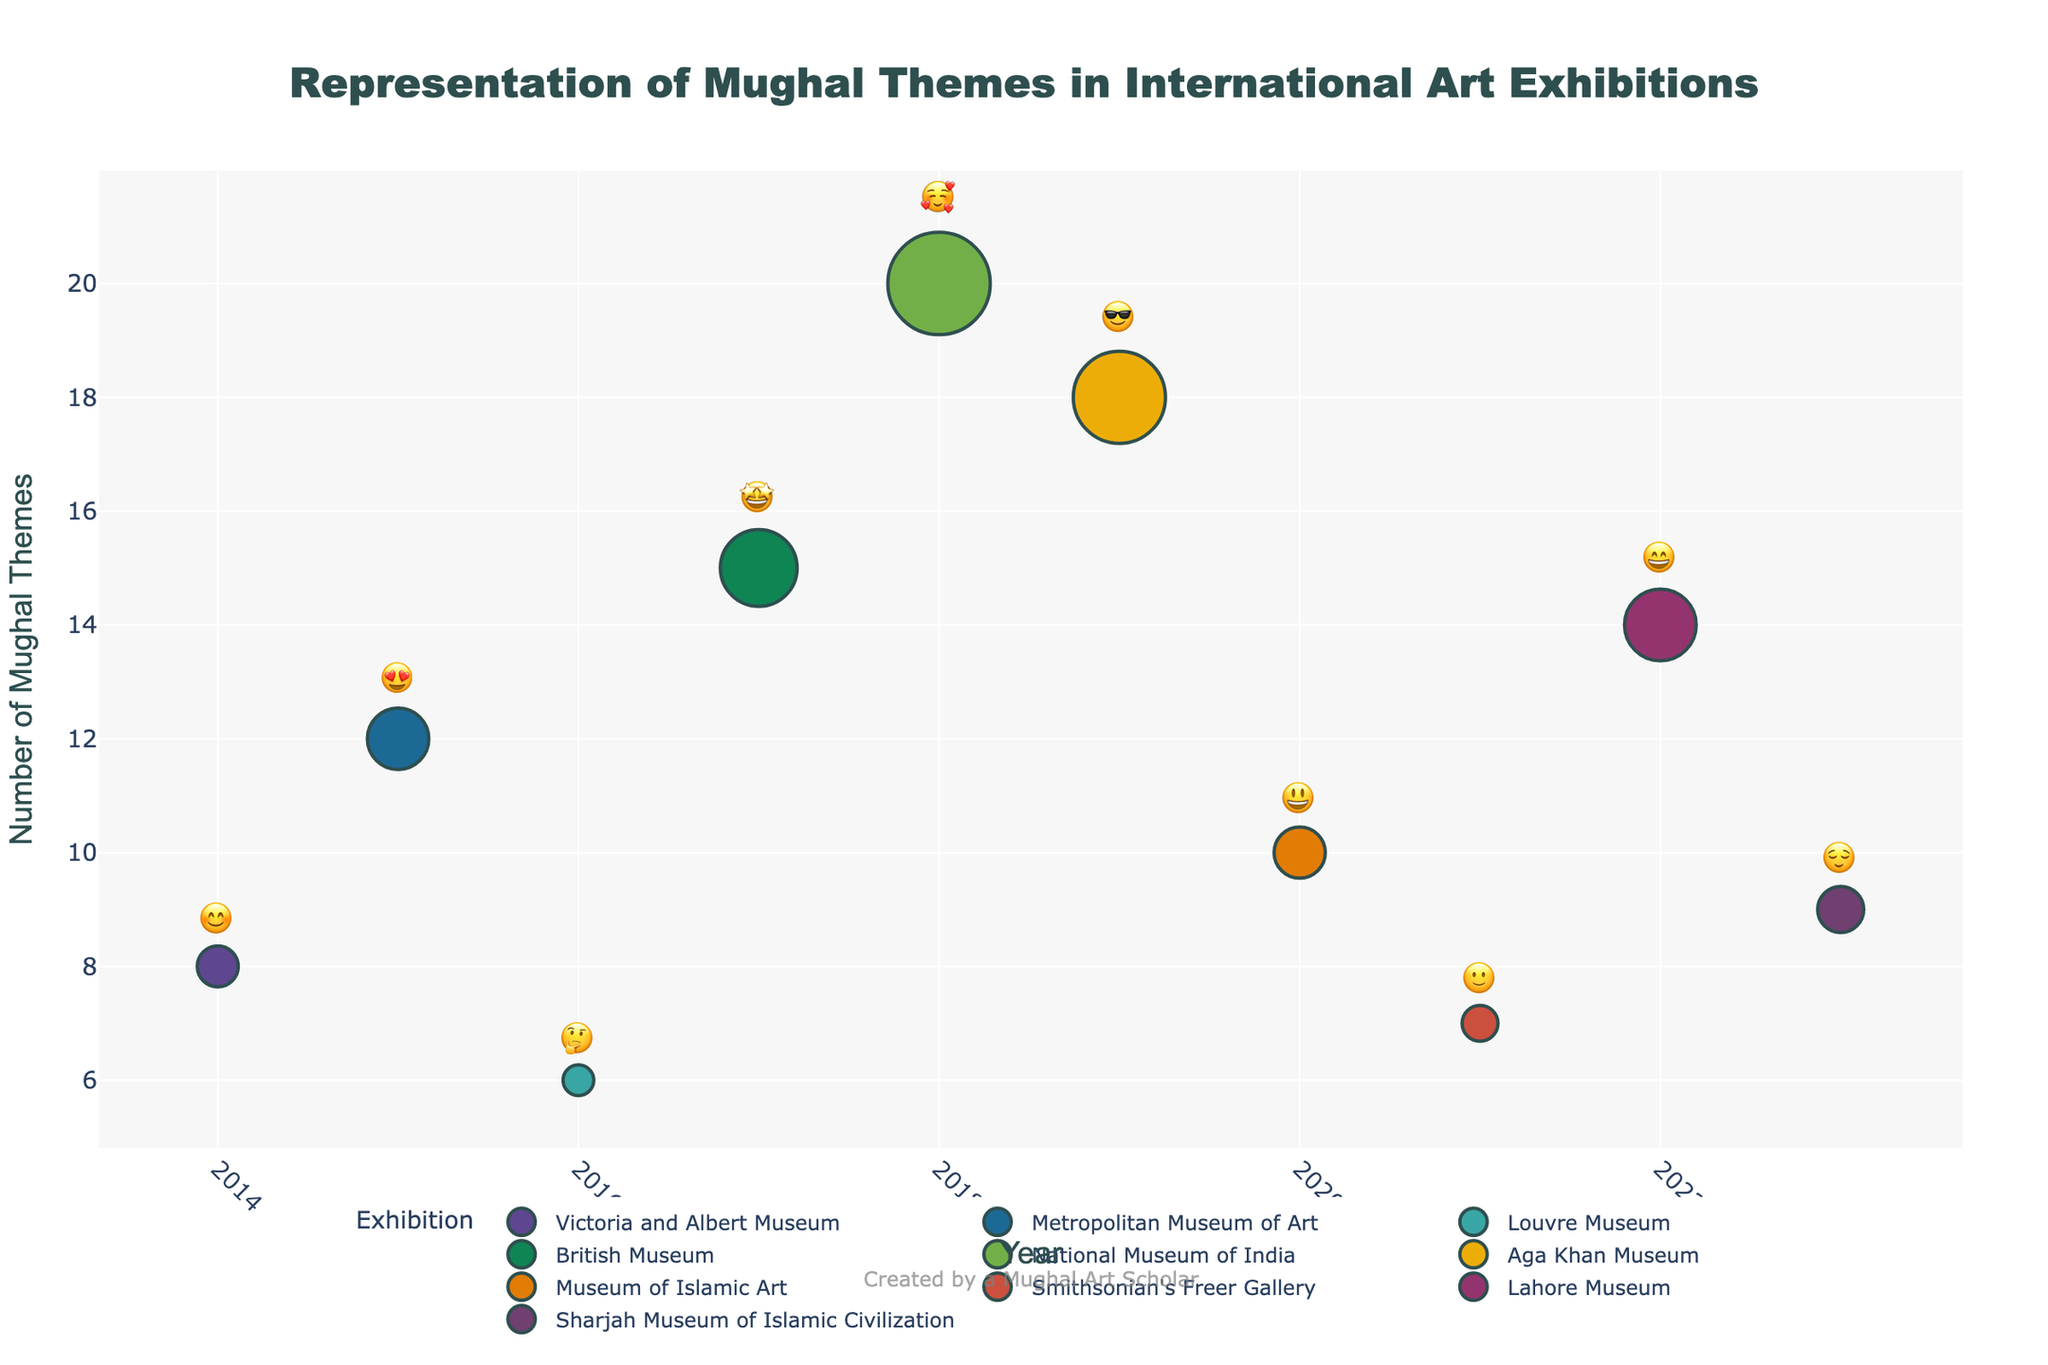What year did the British Museum feature Mughal themes? Locate the data point with the label 'British Museum' and check its corresponding year on the x-axis.
Answer: 2017 Which exhibition had the highest number of Mughal themes? Look for the tallest bubble on the y-axis, which indicates the number of Mughal themes.
Answer: National Museum of India What's the average number of Mughal themes across all exhibitions? Sum the numbers of Mughal themes (8 + 12 + 6 + 15 + 20 + 18 + 10 + 7 + 14 + 9) to get 119. Divide by the number of exhibitions, which is 10.
Answer: 11.9 Which year had the highest visitor engagement based on emojis? Identify the year with the highest positive emoji icon: '🥰'.
Answer: 2018 Compare the number of Mughal themes between the Victoria and Albert Museum and Lahore Museum. Which one had more? Locate the data points for both exhibitions and compare their heights on the y-axis.
Answer: Lahore Museum How many exhibitions had more than 10 Mughal themes? Count all data points with 'Mughal Themes' greater than 10 on the y-axis.
Answer: 5 Which exhibition had the lowest visitor engagement emoji? Identify the emoji with the least enthusiasm, which is '🤔' and check its associated exhibition.
Answer: Louvre Museum What is the difference in the number of Mughal themes between the Aga Khan Museum and the British Museum? Subtract the number of Mughal themes of the British Museum from that of the Aga Khan Museum: 18 - 15.
Answer: 3 In which year did the Smithsonian's Freer Gallery exhibit Mughal themes, and how many themes were there? Find the data point with the label 'Smithsonian's Freer Gallery' and check its year and Mughal themes.
Answer: 2021 and 7 What is the median number of Mughal themes for all exhibitions? Arrange the numbers of Mughal themes in ascending order (6, 7, 8, 9, 10, 12, 14, 15, 18, 20). The median is the middle value of this list.
Answer: 11 